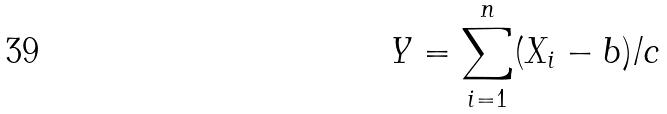Convert formula to latex. <formula><loc_0><loc_0><loc_500><loc_500>Y = \sum _ { i = 1 } ^ { n } ( X _ { i } - b ) / c</formula> 